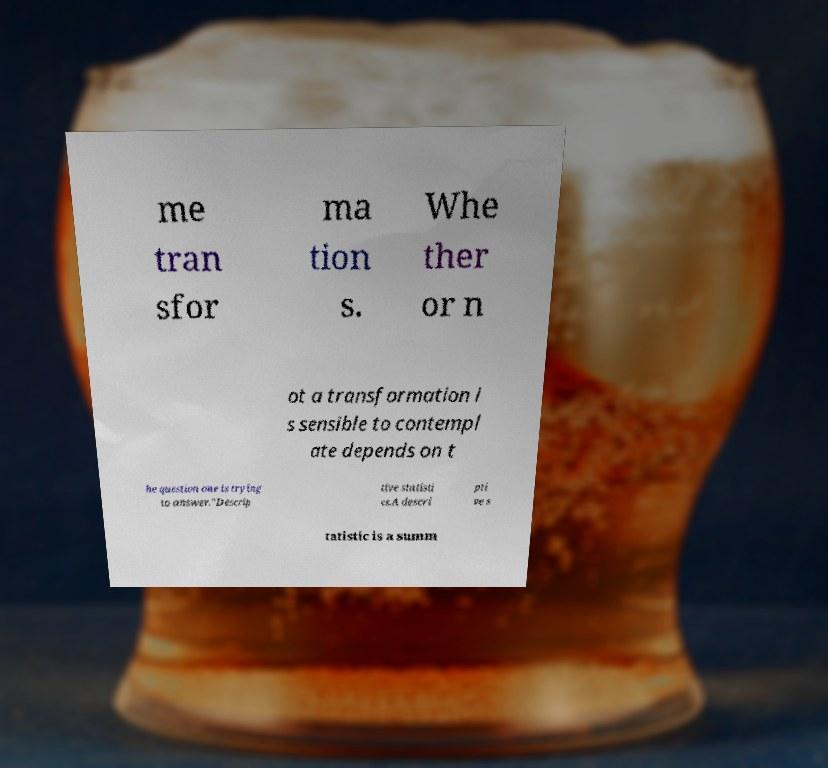Please identify and transcribe the text found in this image. me tran sfor ma tion s. Whe ther or n ot a transformation i s sensible to contempl ate depends on t he question one is trying to answer."Descrip tive statisti cs.A descri pti ve s tatistic is a summ 